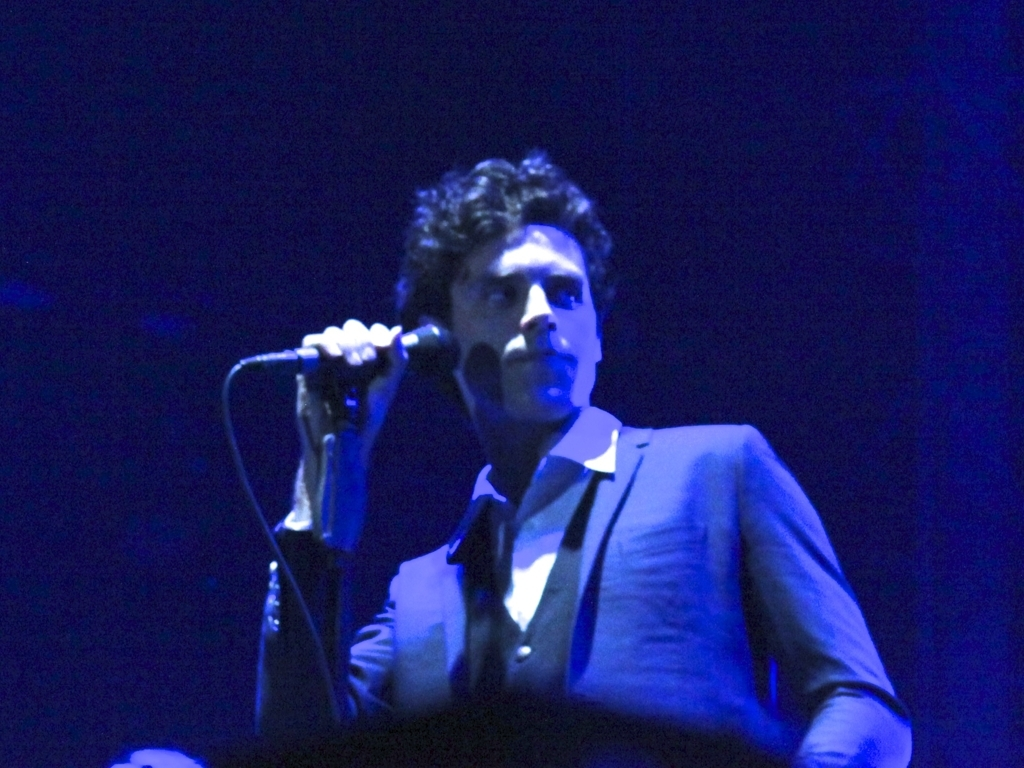Can you comment on the style and attire of the person in the image? Certainly! The individual is wearing a formal suit, which gives a sense of sophistication and professionalism. This attire is often chosen for events where the audience expects a certain level of decorum and artistry. Does the image suggest that the person is the main focus of the event? Yes, the focused lighting and the positioning of the person holding a microphone indicate that they are likely the main attraction, The central positioning and stage presence suggest they are performing or speaking to an audience. 